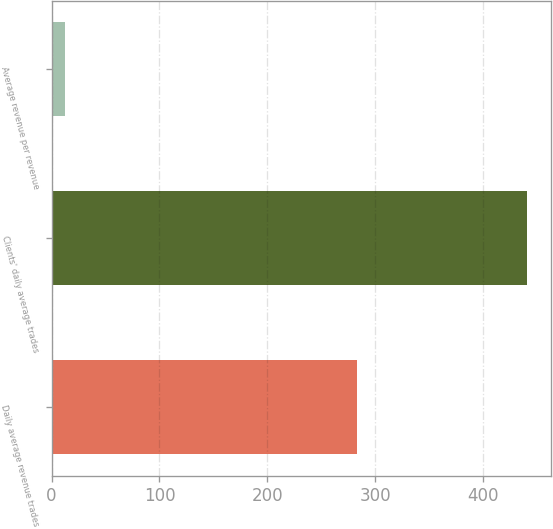Convert chart to OTSL. <chart><loc_0><loc_0><loc_500><loc_500><bar_chart><fcel>Daily average revenue trades<fcel>Clients' daily average trades<fcel>Average revenue per revenue<nl><fcel>282.7<fcel>440.9<fcel>12.35<nl></chart> 